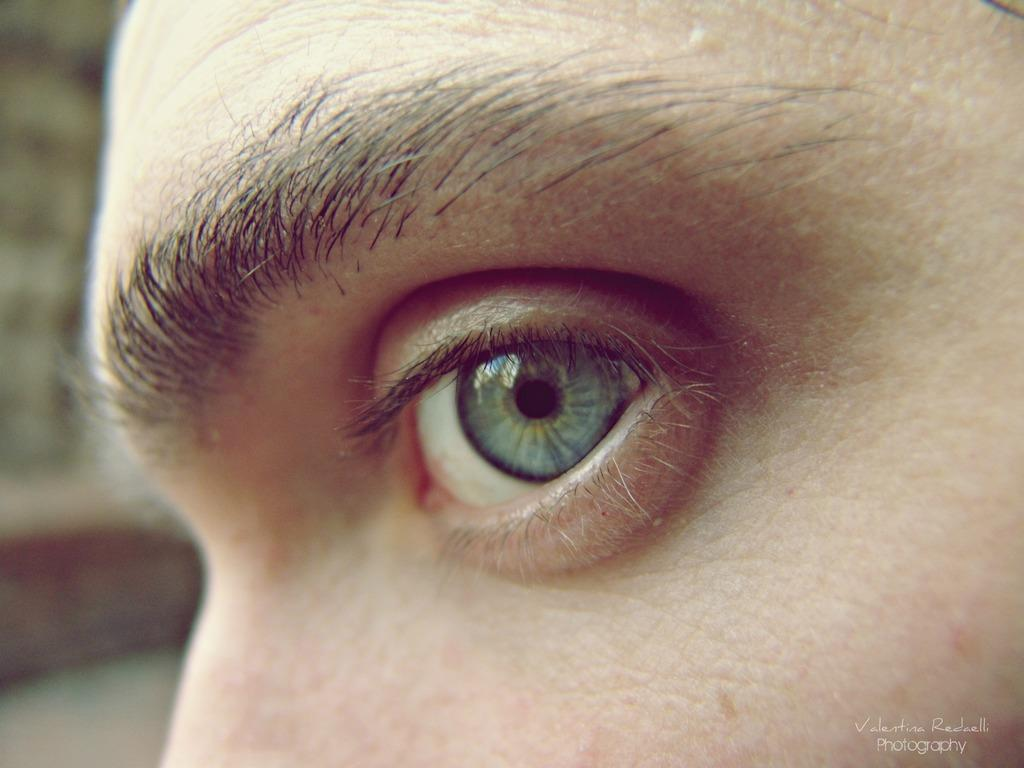What part of the body is visible in the image? An eye and an eyebrow are visible in the image. Where is the watermark located in the image? The watermark is in the right bottom of the image. How many children are playing with corn in the image? There are no children or corn present in the image. 